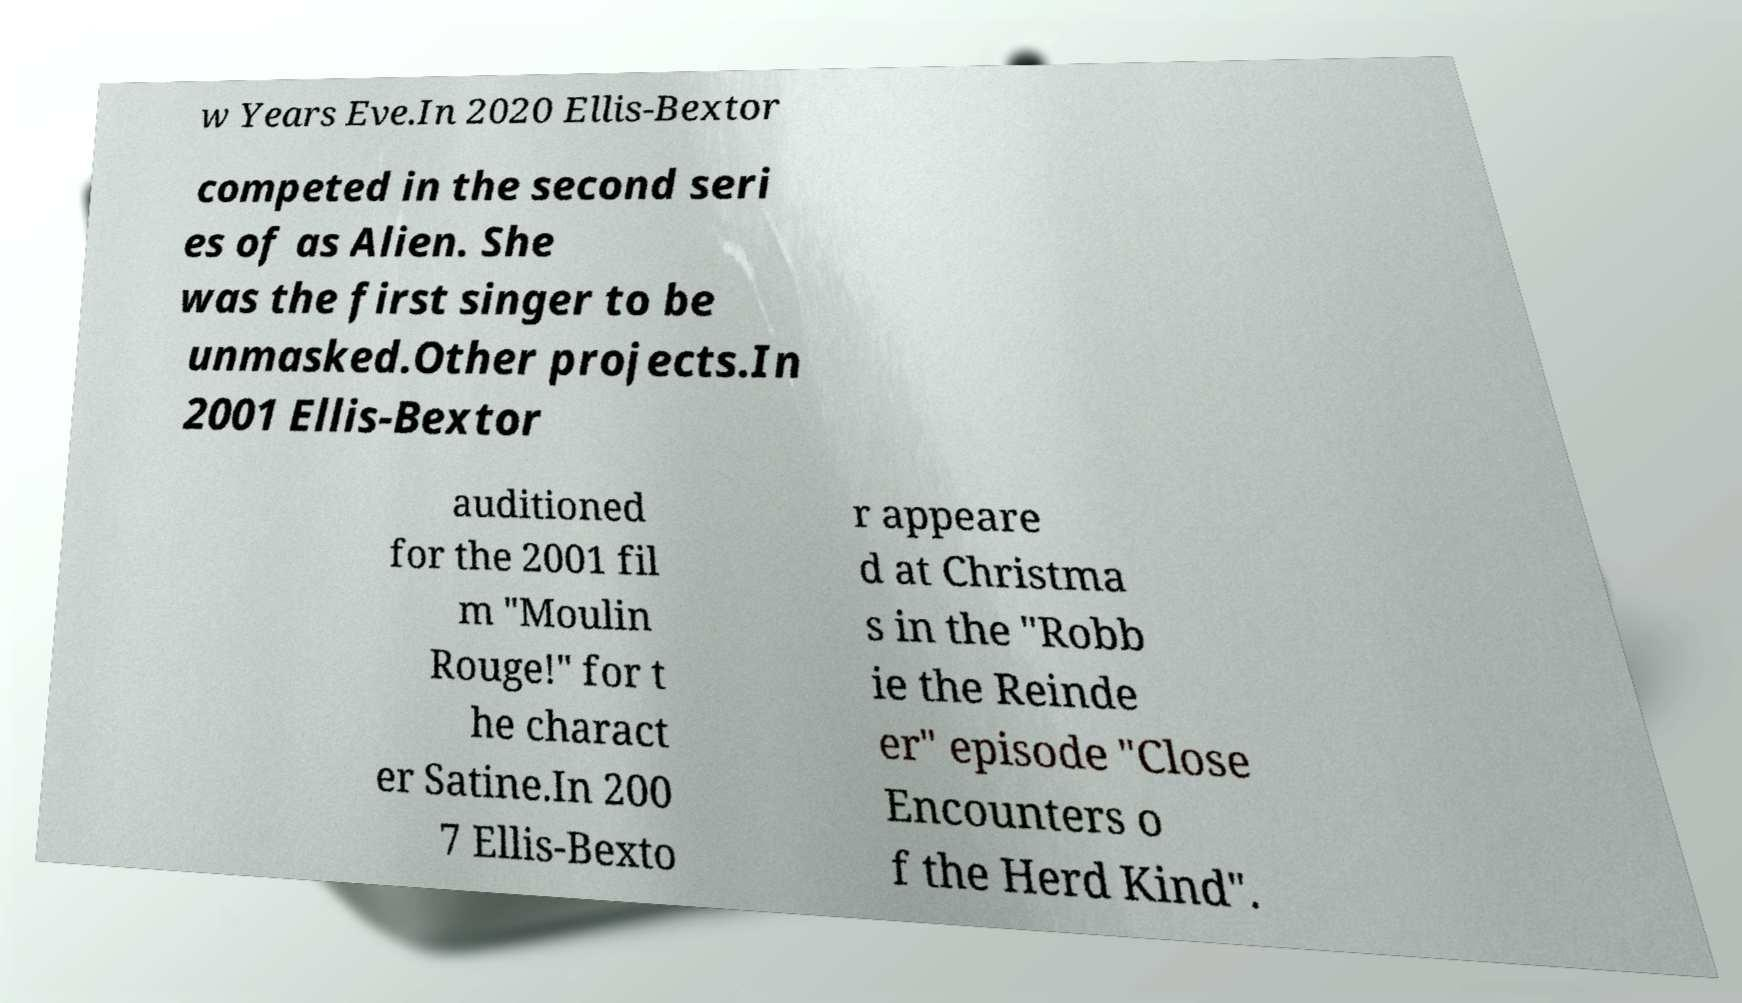Please identify and transcribe the text found in this image. w Years Eve.In 2020 Ellis-Bextor competed in the second seri es of as Alien. She was the first singer to be unmasked.Other projects.In 2001 Ellis-Bextor auditioned for the 2001 fil m "Moulin Rouge!" for t he charact er Satine.In 200 7 Ellis-Bexto r appeare d at Christma s in the "Robb ie the Reinde er" episode "Close Encounters o f the Herd Kind". 